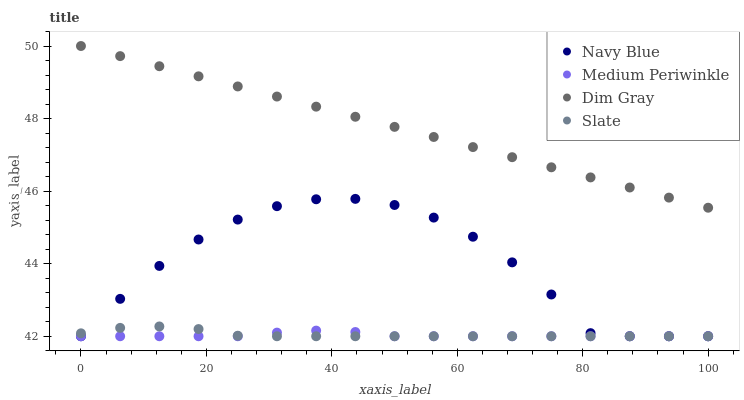Does Medium Periwinkle have the minimum area under the curve?
Answer yes or no. Yes. Does Dim Gray have the maximum area under the curve?
Answer yes or no. Yes. Does Slate have the minimum area under the curve?
Answer yes or no. No. Does Slate have the maximum area under the curve?
Answer yes or no. No. Is Dim Gray the smoothest?
Answer yes or no. Yes. Is Navy Blue the roughest?
Answer yes or no. Yes. Is Slate the smoothest?
Answer yes or no. No. Is Slate the roughest?
Answer yes or no. No. Does Navy Blue have the lowest value?
Answer yes or no. Yes. Does Dim Gray have the lowest value?
Answer yes or no. No. Does Dim Gray have the highest value?
Answer yes or no. Yes. Does Slate have the highest value?
Answer yes or no. No. Is Medium Periwinkle less than Dim Gray?
Answer yes or no. Yes. Is Dim Gray greater than Medium Periwinkle?
Answer yes or no. Yes. Does Medium Periwinkle intersect Navy Blue?
Answer yes or no. Yes. Is Medium Periwinkle less than Navy Blue?
Answer yes or no. No. Is Medium Periwinkle greater than Navy Blue?
Answer yes or no. No. Does Medium Periwinkle intersect Dim Gray?
Answer yes or no. No. 